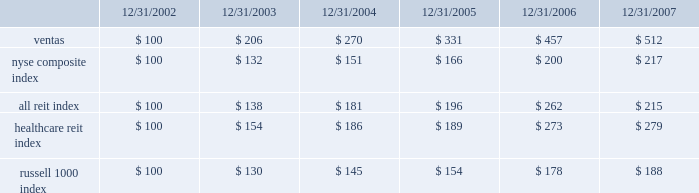Stock performance graph the following performance graph compares the cumulative total return ( including dividends ) to the holders of our common stock from december 31 , 2002 through december 31 , 2007 , with the cumulative total returns of the nyse composite index , the ftse nareit composite reit index ( the 201call reit index 201d ) , the ftse nareit healthcare equity reit index ( the 201chealthcare reit index 201d ) and the russell 1000 index over the same period .
The comparison assumes $ 100 was invested on december 31 , 2002 in our common stock and in each of the foregoing indices and assumes reinvestment of dividends , as applicable .
We have included the nyse composite index in the performance graph because our common stock is listed on the nyse .
We have included the other indices because we believe that they are either most representative of the industry in which we compete , or otherwise provide a fair basis for comparison with ventas , and are therefore particularly relevant to an assessment of our performance .
The figures in the table below are rounded to the nearest dollar. .
Ventas nyse composite index all reit index healthcare reit index russell 1000 index .
What was the growth rate of reit index as of 12/31/2003? 
Rationale: the growth rate is the change from year to year divided by the original year amount
Computations: ((138 - 100) / 100)
Answer: 0.38. Stock performance graph the following performance graph compares the cumulative total return ( including dividends ) to the holders of our common stock from december 31 , 2002 through december 31 , 2007 , with the cumulative total returns of the nyse composite index , the ftse nareit composite reit index ( the 201call reit index 201d ) , the ftse nareit healthcare equity reit index ( the 201chealthcare reit index 201d ) and the russell 1000 index over the same period .
The comparison assumes $ 100 was invested on december 31 , 2002 in our common stock and in each of the foregoing indices and assumes reinvestment of dividends , as applicable .
We have included the nyse composite index in the performance graph because our common stock is listed on the nyse .
We have included the other indices because we believe that they are either most representative of the industry in which we compete , or otherwise provide a fair basis for comparison with ventas , and are therefore particularly relevant to an assessment of our performance .
The figures in the table below are rounded to the nearest dollar. .
Ventas nyse composite index all reit index healthcare reit index russell 1000 index .
What was the growth rate of the ventas stock as of 12/31/2003? 
Rationale: the growth rate is the change from year to year divided by the original year amount
Computations: ((206 - 100) / 100)
Answer: 1.06. Stock performance graph the following performance graph compares the cumulative total return ( including dividends ) to the holders of our common stock from december 31 , 2002 through december 31 , 2007 , with the cumulative total returns of the nyse composite index , the ftse nareit composite reit index ( the 201call reit index 201d ) , the ftse nareit healthcare equity reit index ( the 201chealthcare reit index 201d ) and the russell 1000 index over the same period .
The comparison assumes $ 100 was invested on december 31 , 2002 in our common stock and in each of the foregoing indices and assumes reinvestment of dividends , as applicable .
We have included the nyse composite index in the performance graph because our common stock is listed on the nyse .
We have included the other indices because we believe that they are either most representative of the industry in which we compete , or otherwise provide a fair basis for comparison with ventas , and are therefore particularly relevant to an assessment of our performance .
The figures in the table below are rounded to the nearest dollar. .
Ventas nyse composite index all reit index healthcare reit index russell 1000 index .
What was the 5 year return on ventas common stock? 
Computations: ((512 - 100) / 100)
Answer: 4.12. 